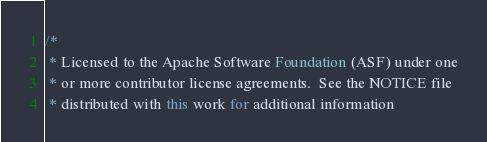Convert code to text. <code><loc_0><loc_0><loc_500><loc_500><_Java_>/*
 * Licensed to the Apache Software Foundation (ASF) under one
 * or more contributor license agreements.  See the NOTICE file
 * distributed with this work for additional information</code> 